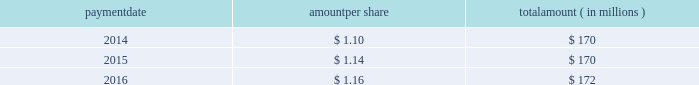Humana inc .
Notes to consolidated financial statements 2014 ( continued ) 15 .
Stockholders 2019 equity as discussed in note 2 , we elected to early adopt new guidance related to accounting for employee share-based payments prospectively effective january 1 , 2016 .
The adoption of this new guidance resulted in the recognition of approximately $ 20 million of tax benefits in net income in our consolidated statement of income for the three months ended march 31 , 2016 that had previously been recorded as additional paid-in capital in our consolidated balance sheet .
Dividends the table provides details of dividend payments , excluding dividend equivalent rights , in 2014 , 2015 , and 2016 under our board approved quarterly cash dividend policy : payment amount per share amount ( in millions ) .
Under the terms of the merger agreement , we agreed with aetna that our quarterly dividend would not exceed $ 0.29 per share prior to the closing or termination of the merger .
On october 26 , 2016 , the board declared a cash dividend of $ 0.29 per share that was paid on january 27 , 2017 to stockholders of record on january 12 , 2017 , for an aggregate amount of $ 43 million .
On february 14 , 2017 , following the termination of the merger agreement , the board declared a cash dividend of $ 0.40 per share , to be paid on april 28 , 2017 , to the stockholders of record on march 31 , 2017 .
Declaration and payment of future quarterly dividends is at the discretion of our board and may be adjusted as business needs or market conditions change .
Stock repurchases in september 2014 , our board of directors replaced a previous share repurchase authorization of up to $ 1 billion ( of which $ 816 million remained unused ) with an authorization for repurchases of up to $ 2 billion of our common shares exclusive of shares repurchased in connection with employee stock plans , which expired on december 31 , 2016 .
Under the share repurchase authorization , shares may have been purchased from time to time at prevailing prices in the open market , by block purchases , through plans designed to comply with rule 10b5-1 under the securities exchange act of 1934 , as amended , or in privately-negotiated transactions ( including pursuant to accelerated share repurchase agreements with investment banks ) , subject to certain regulatory restrictions on volume , pricing , and timing .
Pursuant to the merger agreement , after july 2 , 2015 , we were prohibited from repurchasing any of our outstanding securities without the prior written consent of aetna , other than repurchases of shares of our common stock in connection with the exercise of outstanding stock options or the vesting or settlement of outstanding restricted stock awards .
Accordingly , as announced on july 3 , 2015 , we suspended our share repurchase program. .
Considering the year 2014 , what is the amount of issued shares , in millions? 
Rationale: it is the value of shares payment divided by the price per share to discover the number of shares issued and paid .
Computations: (170 / 1.10)
Answer: 154.54545. 